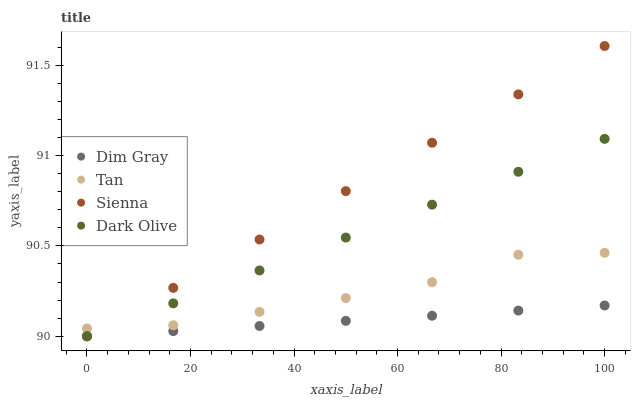Does Dim Gray have the minimum area under the curve?
Answer yes or no. Yes. Does Sienna have the maximum area under the curve?
Answer yes or no. Yes. Does Tan have the minimum area under the curve?
Answer yes or no. No. Does Tan have the maximum area under the curve?
Answer yes or no. No. Is Dark Olive the smoothest?
Answer yes or no. Yes. Is Tan the roughest?
Answer yes or no. Yes. Is Dim Gray the smoothest?
Answer yes or no. No. Is Dim Gray the roughest?
Answer yes or no. No. Does Sienna have the lowest value?
Answer yes or no. Yes. Does Tan have the lowest value?
Answer yes or no. No. Does Sienna have the highest value?
Answer yes or no. Yes. Does Tan have the highest value?
Answer yes or no. No. Is Dim Gray less than Tan?
Answer yes or no. Yes. Is Tan greater than Dim Gray?
Answer yes or no. Yes. Does Tan intersect Dark Olive?
Answer yes or no. Yes. Is Tan less than Dark Olive?
Answer yes or no. No. Is Tan greater than Dark Olive?
Answer yes or no. No. Does Dim Gray intersect Tan?
Answer yes or no. No. 